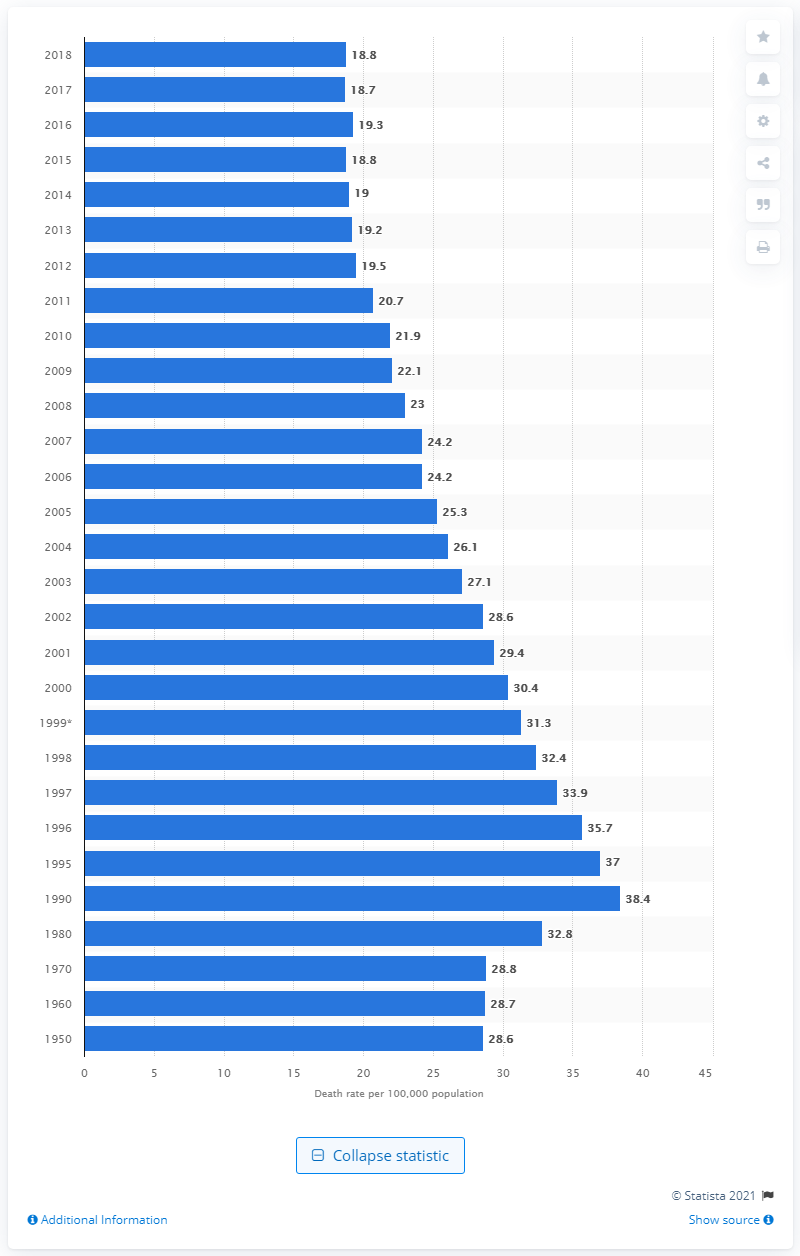Draw attention to some important aspects in this diagram. In the United States in 2018, the death rate for prostate cancer per 100,000 men was 18.8. 